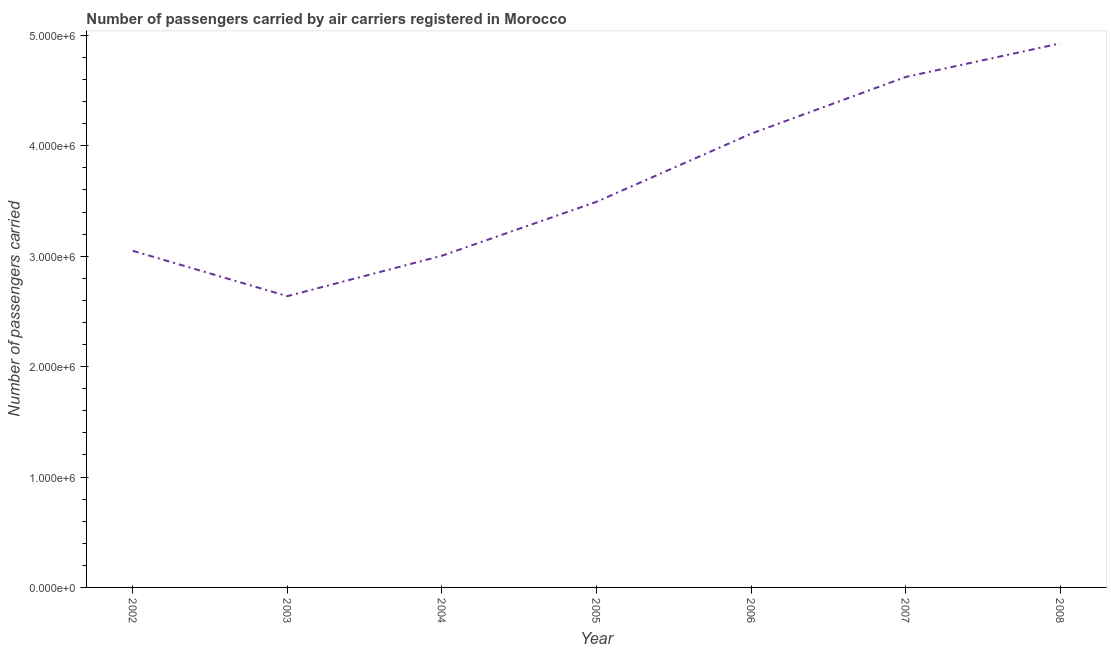What is the number of passengers carried in 2002?
Your response must be concise. 3.05e+06. Across all years, what is the maximum number of passengers carried?
Your answer should be compact. 4.93e+06. Across all years, what is the minimum number of passengers carried?
Give a very brief answer. 2.64e+06. In which year was the number of passengers carried maximum?
Keep it short and to the point. 2008. In which year was the number of passengers carried minimum?
Offer a terse response. 2003. What is the sum of the number of passengers carried?
Your answer should be compact. 2.58e+07. What is the difference between the number of passengers carried in 2002 and 2004?
Give a very brief answer. 4.48e+04. What is the average number of passengers carried per year?
Give a very brief answer. 3.69e+06. What is the median number of passengers carried?
Your answer should be very brief. 3.49e+06. What is the ratio of the number of passengers carried in 2004 to that in 2008?
Make the answer very short. 0.61. Is the difference between the number of passengers carried in 2004 and 2006 greater than the difference between any two years?
Offer a very short reply. No. What is the difference between the highest and the second highest number of passengers carried?
Offer a very short reply. 3.04e+05. What is the difference between the highest and the lowest number of passengers carried?
Your response must be concise. 2.29e+06. In how many years, is the number of passengers carried greater than the average number of passengers carried taken over all years?
Provide a short and direct response. 3. Does the number of passengers carried monotonically increase over the years?
Your answer should be compact. No. How many lines are there?
Your response must be concise. 1. What is the difference between two consecutive major ticks on the Y-axis?
Offer a very short reply. 1.00e+06. Are the values on the major ticks of Y-axis written in scientific E-notation?
Keep it short and to the point. Yes. Does the graph contain grids?
Offer a terse response. No. What is the title of the graph?
Offer a very short reply. Number of passengers carried by air carriers registered in Morocco. What is the label or title of the Y-axis?
Make the answer very short. Number of passengers carried. What is the Number of passengers carried of 2002?
Make the answer very short. 3.05e+06. What is the Number of passengers carried in 2003?
Your answer should be compact. 2.64e+06. What is the Number of passengers carried of 2004?
Offer a very short reply. 3.00e+06. What is the Number of passengers carried of 2005?
Ensure brevity in your answer.  3.49e+06. What is the Number of passengers carried in 2006?
Provide a succinct answer. 4.11e+06. What is the Number of passengers carried in 2007?
Offer a very short reply. 4.62e+06. What is the Number of passengers carried in 2008?
Give a very brief answer. 4.93e+06. What is the difference between the Number of passengers carried in 2002 and 2003?
Offer a terse response. 4.11e+05. What is the difference between the Number of passengers carried in 2002 and 2004?
Keep it short and to the point. 4.48e+04. What is the difference between the Number of passengers carried in 2002 and 2005?
Make the answer very short. -4.44e+05. What is the difference between the Number of passengers carried in 2002 and 2006?
Provide a short and direct response. -1.06e+06. What is the difference between the Number of passengers carried in 2002 and 2007?
Your answer should be compact. -1.57e+06. What is the difference between the Number of passengers carried in 2002 and 2008?
Keep it short and to the point. -1.88e+06. What is the difference between the Number of passengers carried in 2003 and 2004?
Make the answer very short. -3.66e+05. What is the difference between the Number of passengers carried in 2003 and 2005?
Give a very brief answer. -8.55e+05. What is the difference between the Number of passengers carried in 2003 and 2006?
Provide a succinct answer. -1.47e+06. What is the difference between the Number of passengers carried in 2003 and 2007?
Provide a succinct answer. -1.99e+06. What is the difference between the Number of passengers carried in 2003 and 2008?
Keep it short and to the point. -2.29e+06. What is the difference between the Number of passengers carried in 2004 and 2005?
Give a very brief answer. -4.89e+05. What is the difference between the Number of passengers carried in 2004 and 2006?
Offer a terse response. -1.11e+06. What is the difference between the Number of passengers carried in 2004 and 2007?
Offer a terse response. -1.62e+06. What is the difference between the Number of passengers carried in 2004 and 2008?
Make the answer very short. -1.92e+06. What is the difference between the Number of passengers carried in 2005 and 2006?
Provide a succinct answer. -6.17e+05. What is the difference between the Number of passengers carried in 2005 and 2007?
Your answer should be compact. -1.13e+06. What is the difference between the Number of passengers carried in 2005 and 2008?
Make the answer very short. -1.43e+06. What is the difference between the Number of passengers carried in 2006 and 2007?
Your answer should be compact. -5.14e+05. What is the difference between the Number of passengers carried in 2006 and 2008?
Give a very brief answer. -8.18e+05. What is the difference between the Number of passengers carried in 2007 and 2008?
Offer a terse response. -3.04e+05. What is the ratio of the Number of passengers carried in 2002 to that in 2003?
Provide a succinct answer. 1.16. What is the ratio of the Number of passengers carried in 2002 to that in 2004?
Provide a succinct answer. 1.01. What is the ratio of the Number of passengers carried in 2002 to that in 2005?
Your answer should be compact. 0.87. What is the ratio of the Number of passengers carried in 2002 to that in 2006?
Ensure brevity in your answer.  0.74. What is the ratio of the Number of passengers carried in 2002 to that in 2007?
Ensure brevity in your answer.  0.66. What is the ratio of the Number of passengers carried in 2002 to that in 2008?
Keep it short and to the point. 0.62. What is the ratio of the Number of passengers carried in 2003 to that in 2004?
Provide a succinct answer. 0.88. What is the ratio of the Number of passengers carried in 2003 to that in 2005?
Give a very brief answer. 0.76. What is the ratio of the Number of passengers carried in 2003 to that in 2006?
Give a very brief answer. 0.64. What is the ratio of the Number of passengers carried in 2003 to that in 2007?
Provide a succinct answer. 0.57. What is the ratio of the Number of passengers carried in 2003 to that in 2008?
Make the answer very short. 0.54. What is the ratio of the Number of passengers carried in 2004 to that in 2005?
Provide a succinct answer. 0.86. What is the ratio of the Number of passengers carried in 2004 to that in 2006?
Keep it short and to the point. 0.73. What is the ratio of the Number of passengers carried in 2004 to that in 2007?
Make the answer very short. 0.65. What is the ratio of the Number of passengers carried in 2004 to that in 2008?
Keep it short and to the point. 0.61. What is the ratio of the Number of passengers carried in 2005 to that in 2006?
Give a very brief answer. 0.85. What is the ratio of the Number of passengers carried in 2005 to that in 2007?
Provide a short and direct response. 0.76. What is the ratio of the Number of passengers carried in 2005 to that in 2008?
Your answer should be compact. 0.71. What is the ratio of the Number of passengers carried in 2006 to that in 2007?
Offer a very short reply. 0.89. What is the ratio of the Number of passengers carried in 2006 to that in 2008?
Make the answer very short. 0.83. What is the ratio of the Number of passengers carried in 2007 to that in 2008?
Keep it short and to the point. 0.94. 